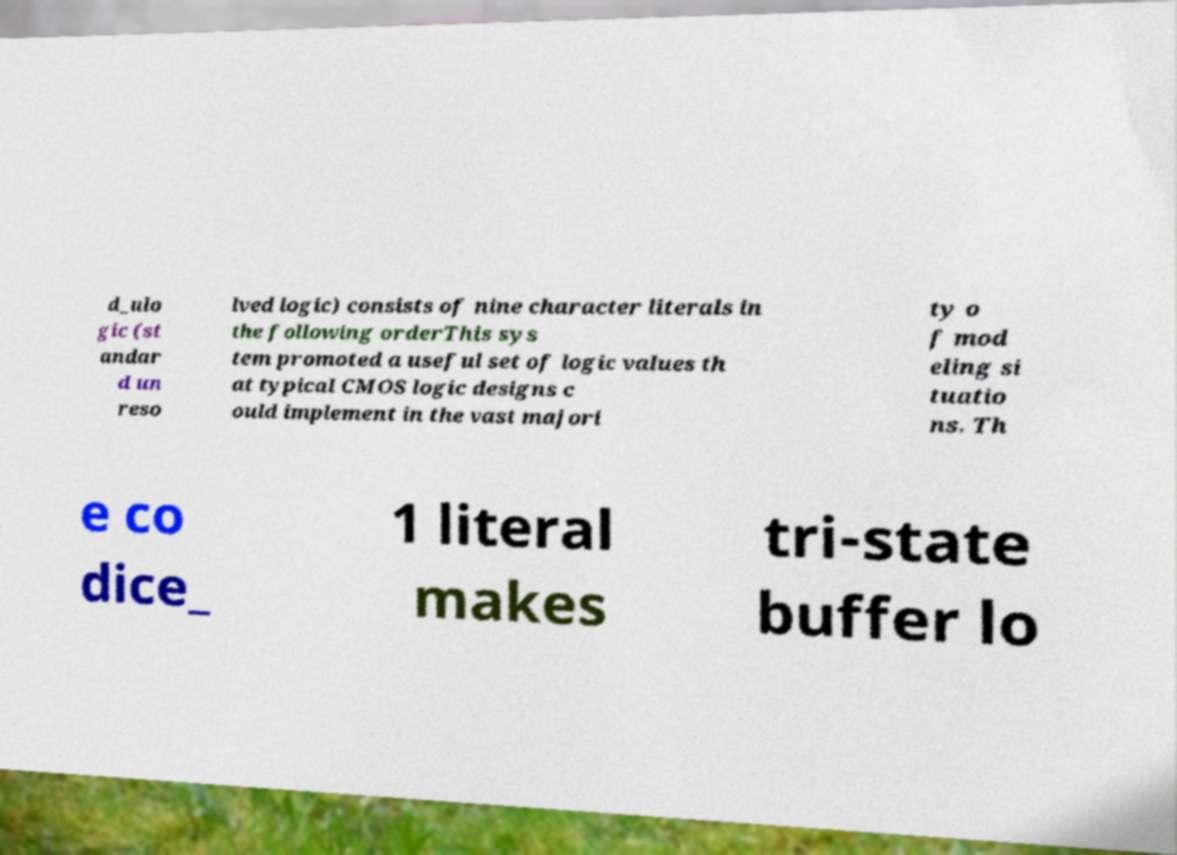Can you accurately transcribe the text from the provided image for me? d_ulo gic (st andar d un reso lved logic) consists of nine character literals in the following orderThis sys tem promoted a useful set of logic values th at typical CMOS logic designs c ould implement in the vast majori ty o f mod eling si tuatio ns. Th e co dice_ 1 literal makes tri-state buffer lo 